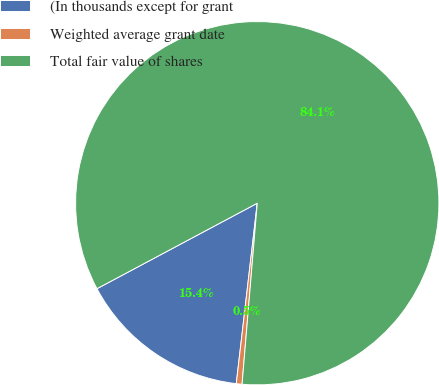Convert chart to OTSL. <chart><loc_0><loc_0><loc_500><loc_500><pie_chart><fcel>(In thousands except for grant<fcel>Weighted average grant date<fcel>Total fair value of shares<nl><fcel>15.36%<fcel>0.51%<fcel>84.13%<nl></chart> 